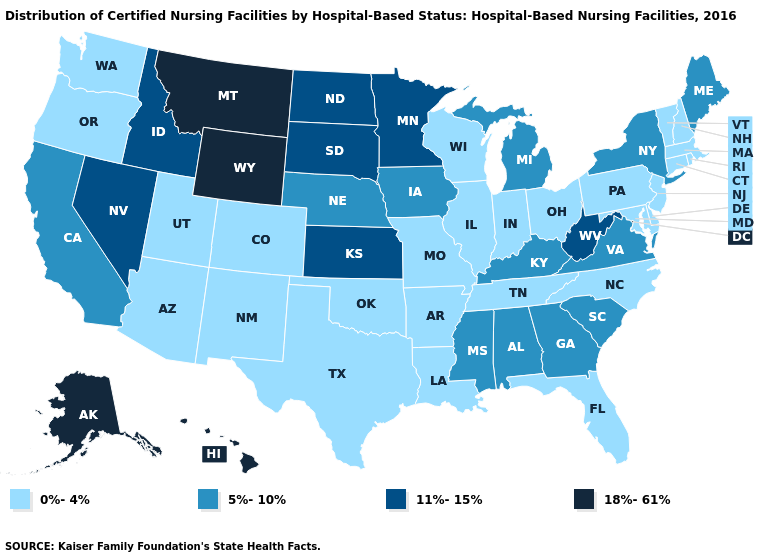Does Kentucky have the same value as Georgia?
Give a very brief answer. Yes. What is the lowest value in the USA?
Quick response, please. 0%-4%. What is the lowest value in the USA?
Be succinct. 0%-4%. What is the highest value in the USA?
Answer briefly. 18%-61%. What is the lowest value in the MidWest?
Give a very brief answer. 0%-4%. Name the states that have a value in the range 18%-61%?
Concise answer only. Alaska, Hawaii, Montana, Wyoming. Name the states that have a value in the range 18%-61%?
Be succinct. Alaska, Hawaii, Montana, Wyoming. What is the highest value in the USA?
Keep it brief. 18%-61%. What is the value of California?
Write a very short answer. 5%-10%. Does New York have the highest value in the Northeast?
Be succinct. Yes. What is the value of Arizona?
Give a very brief answer. 0%-4%. Among the states that border Washington , which have the lowest value?
Be succinct. Oregon. Which states have the lowest value in the MidWest?
Short answer required. Illinois, Indiana, Missouri, Ohio, Wisconsin. What is the value of Massachusetts?
Concise answer only. 0%-4%. Does the map have missing data?
Short answer required. No. 